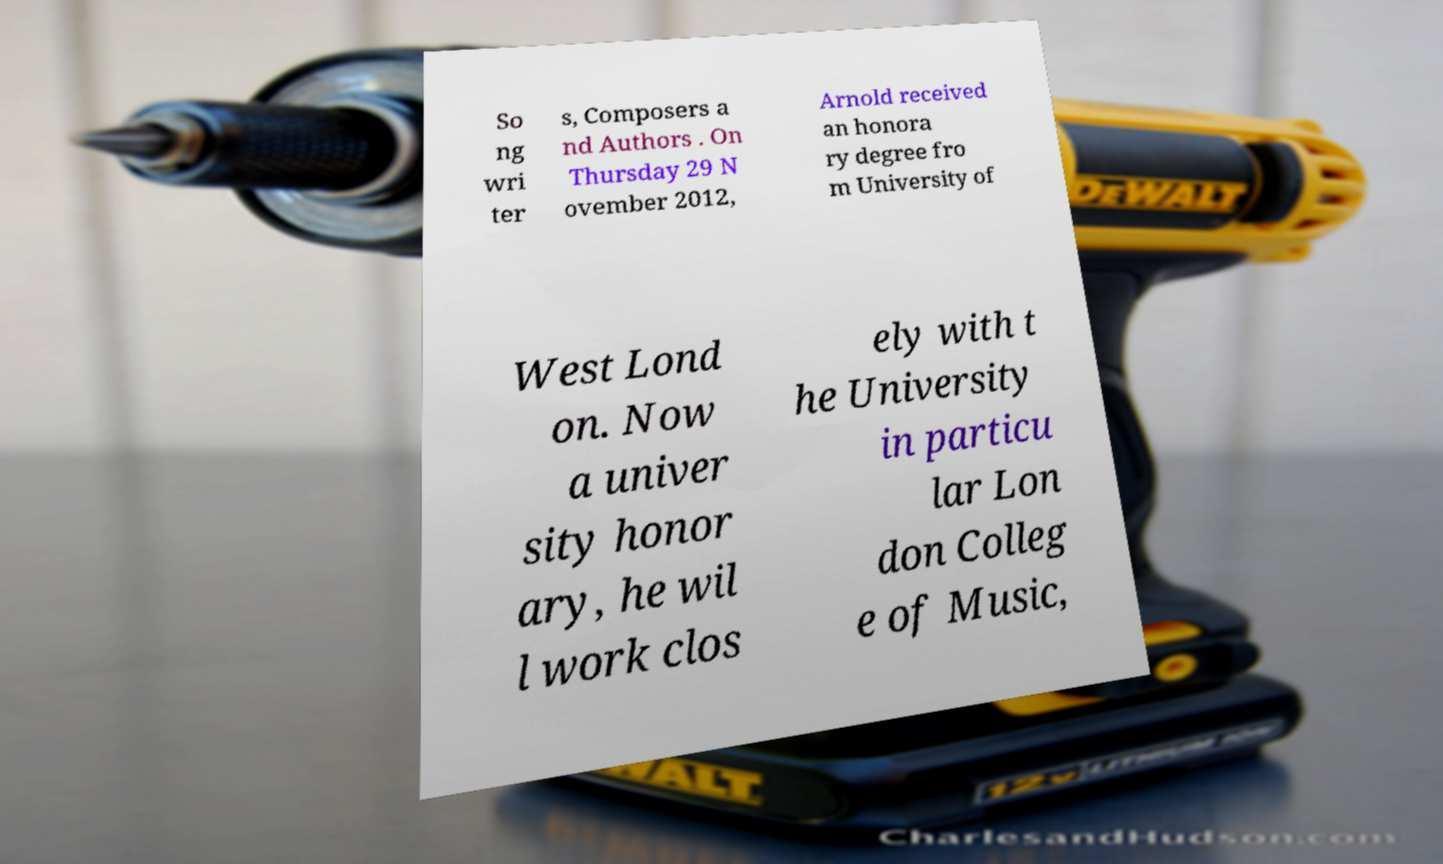Could you extract and type out the text from this image? So ng wri ter s, Composers a nd Authors . On Thursday 29 N ovember 2012, Arnold received an honora ry degree fro m University of West Lond on. Now a univer sity honor ary, he wil l work clos ely with t he University in particu lar Lon don Colleg e of Music, 